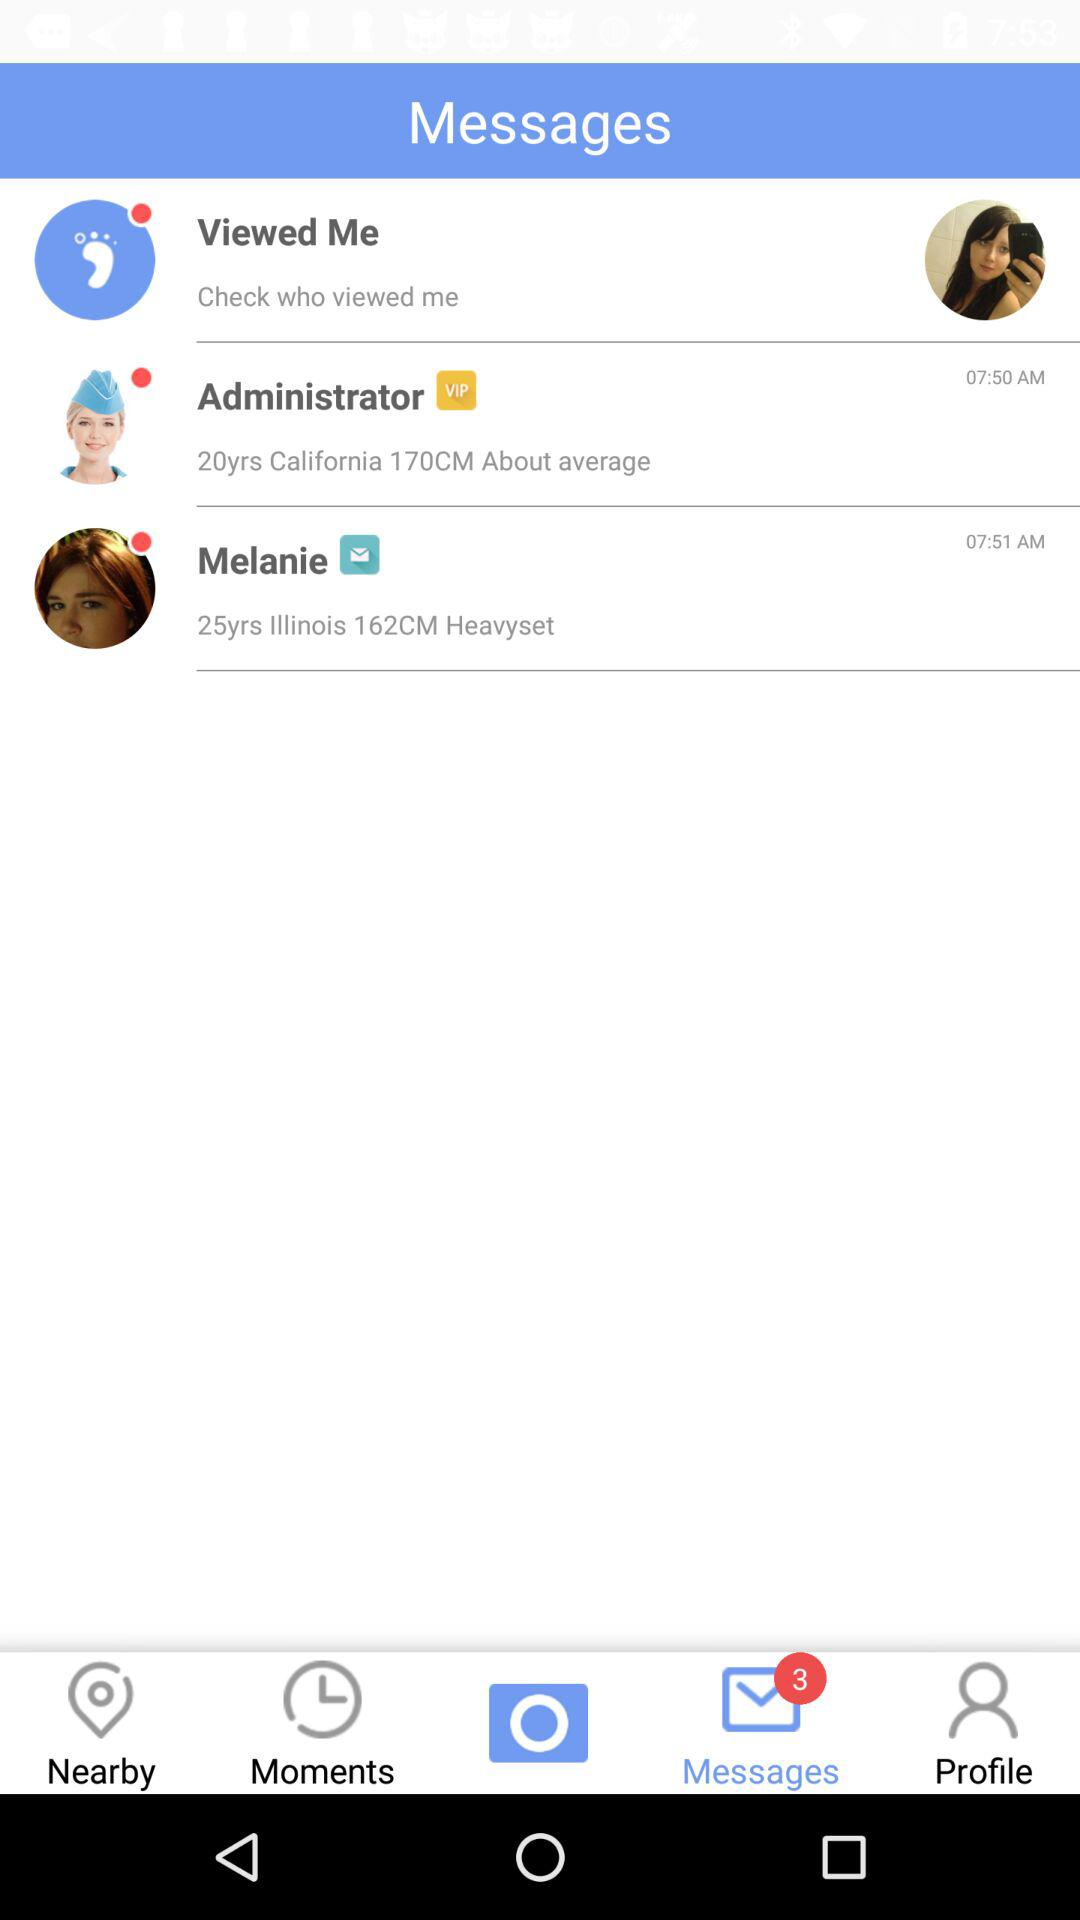Is there any unread messages?
When the provided information is insufficient, respond with <no answer>. <no answer> 